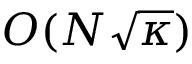Convert formula to latex. <formula><loc_0><loc_0><loc_500><loc_500>O ( N { \sqrt { \kappa } } )</formula> 